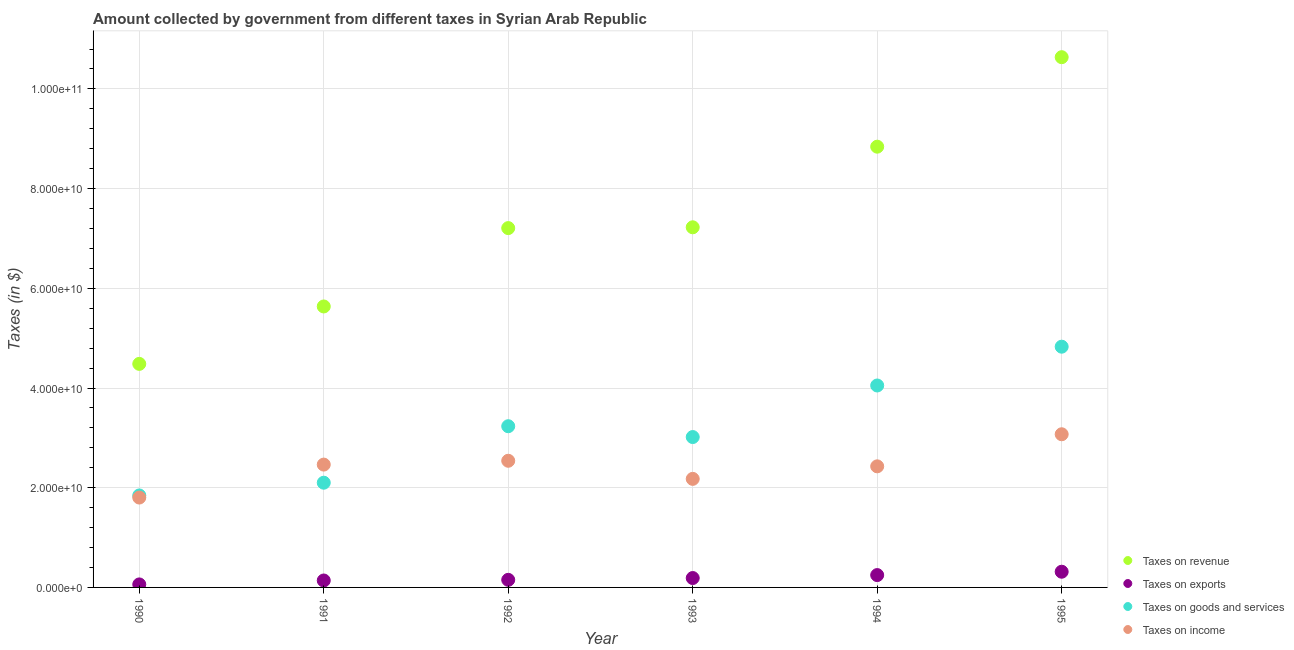How many different coloured dotlines are there?
Give a very brief answer. 4. Is the number of dotlines equal to the number of legend labels?
Keep it short and to the point. Yes. What is the amount collected as tax on exports in 1992?
Provide a succinct answer. 1.52e+09. Across all years, what is the maximum amount collected as tax on income?
Your answer should be very brief. 3.07e+1. Across all years, what is the minimum amount collected as tax on income?
Offer a terse response. 1.80e+1. In which year was the amount collected as tax on revenue maximum?
Make the answer very short. 1995. In which year was the amount collected as tax on goods minimum?
Offer a terse response. 1990. What is the total amount collected as tax on goods in the graph?
Provide a short and direct response. 1.91e+11. What is the difference between the amount collected as tax on revenue in 1991 and that in 1992?
Provide a short and direct response. -1.57e+1. What is the difference between the amount collected as tax on revenue in 1994 and the amount collected as tax on exports in 1995?
Give a very brief answer. 8.53e+1. What is the average amount collected as tax on exports per year?
Offer a terse response. 1.84e+09. In the year 1991, what is the difference between the amount collected as tax on goods and amount collected as tax on revenue?
Ensure brevity in your answer.  -3.54e+1. What is the ratio of the amount collected as tax on exports in 1990 to that in 1991?
Offer a terse response. 0.43. Is the amount collected as tax on exports in 1991 less than that in 1995?
Ensure brevity in your answer.  Yes. What is the difference between the highest and the second highest amount collected as tax on goods?
Offer a very short reply. 7.78e+09. What is the difference between the highest and the lowest amount collected as tax on exports?
Offer a terse response. 2.54e+09. Is it the case that in every year, the sum of the amount collected as tax on goods and amount collected as tax on exports is greater than the sum of amount collected as tax on income and amount collected as tax on revenue?
Ensure brevity in your answer.  Yes. Does the amount collected as tax on exports monotonically increase over the years?
Your answer should be very brief. Yes. How many dotlines are there?
Offer a very short reply. 4. What is the difference between two consecutive major ticks on the Y-axis?
Offer a terse response. 2.00e+1. How are the legend labels stacked?
Your response must be concise. Vertical. What is the title of the graph?
Ensure brevity in your answer.  Amount collected by government from different taxes in Syrian Arab Republic. Does "Coal" appear as one of the legend labels in the graph?
Give a very brief answer. No. What is the label or title of the X-axis?
Give a very brief answer. Year. What is the label or title of the Y-axis?
Give a very brief answer. Taxes (in $). What is the Taxes (in $) in Taxes on revenue in 1990?
Provide a succinct answer. 4.48e+1. What is the Taxes (in $) in Taxes on exports in 1990?
Your response must be concise. 6.04e+08. What is the Taxes (in $) of Taxes on goods and services in 1990?
Ensure brevity in your answer.  1.85e+1. What is the Taxes (in $) of Taxes on income in 1990?
Your answer should be compact. 1.80e+1. What is the Taxes (in $) of Taxes on revenue in 1991?
Ensure brevity in your answer.  5.64e+1. What is the Taxes (in $) of Taxes on exports in 1991?
Your answer should be compact. 1.39e+09. What is the Taxes (in $) in Taxes on goods and services in 1991?
Keep it short and to the point. 2.10e+1. What is the Taxes (in $) of Taxes on income in 1991?
Make the answer very short. 2.46e+1. What is the Taxes (in $) of Taxes on revenue in 1992?
Ensure brevity in your answer.  7.21e+1. What is the Taxes (in $) in Taxes on exports in 1992?
Ensure brevity in your answer.  1.52e+09. What is the Taxes (in $) in Taxes on goods and services in 1992?
Give a very brief answer. 3.23e+1. What is the Taxes (in $) in Taxes on income in 1992?
Keep it short and to the point. 2.54e+1. What is the Taxes (in $) in Taxes on revenue in 1993?
Offer a terse response. 7.22e+1. What is the Taxes (in $) in Taxes on exports in 1993?
Make the answer very short. 1.88e+09. What is the Taxes (in $) in Taxes on goods and services in 1993?
Your answer should be compact. 3.02e+1. What is the Taxes (in $) of Taxes on income in 1993?
Your answer should be very brief. 2.18e+1. What is the Taxes (in $) of Taxes on revenue in 1994?
Ensure brevity in your answer.  8.84e+1. What is the Taxes (in $) in Taxes on exports in 1994?
Provide a succinct answer. 2.48e+09. What is the Taxes (in $) in Taxes on goods and services in 1994?
Offer a very short reply. 4.05e+1. What is the Taxes (in $) in Taxes on income in 1994?
Your answer should be very brief. 2.43e+1. What is the Taxes (in $) of Taxes on revenue in 1995?
Your response must be concise. 1.06e+11. What is the Taxes (in $) in Taxes on exports in 1995?
Ensure brevity in your answer.  3.15e+09. What is the Taxes (in $) in Taxes on goods and services in 1995?
Give a very brief answer. 4.83e+1. What is the Taxes (in $) of Taxes on income in 1995?
Provide a succinct answer. 3.07e+1. Across all years, what is the maximum Taxes (in $) in Taxes on revenue?
Make the answer very short. 1.06e+11. Across all years, what is the maximum Taxes (in $) of Taxes on exports?
Keep it short and to the point. 3.15e+09. Across all years, what is the maximum Taxes (in $) in Taxes on goods and services?
Provide a succinct answer. 4.83e+1. Across all years, what is the maximum Taxes (in $) of Taxes on income?
Provide a short and direct response. 3.07e+1. Across all years, what is the minimum Taxes (in $) in Taxes on revenue?
Provide a short and direct response. 4.48e+1. Across all years, what is the minimum Taxes (in $) of Taxes on exports?
Offer a terse response. 6.04e+08. Across all years, what is the minimum Taxes (in $) of Taxes on goods and services?
Provide a short and direct response. 1.85e+1. Across all years, what is the minimum Taxes (in $) of Taxes on income?
Your response must be concise. 1.80e+1. What is the total Taxes (in $) in Taxes on revenue in the graph?
Keep it short and to the point. 4.40e+11. What is the total Taxes (in $) in Taxes on exports in the graph?
Keep it short and to the point. 1.10e+1. What is the total Taxes (in $) of Taxes on goods and services in the graph?
Your answer should be compact. 1.91e+11. What is the total Taxes (in $) of Taxes on income in the graph?
Give a very brief answer. 1.45e+11. What is the difference between the Taxes (in $) in Taxes on revenue in 1990 and that in 1991?
Keep it short and to the point. -1.15e+1. What is the difference between the Taxes (in $) of Taxes on exports in 1990 and that in 1991?
Your answer should be very brief. -7.88e+08. What is the difference between the Taxes (in $) of Taxes on goods and services in 1990 and that in 1991?
Provide a succinct answer. -2.56e+09. What is the difference between the Taxes (in $) in Taxes on income in 1990 and that in 1991?
Provide a short and direct response. -6.61e+09. What is the difference between the Taxes (in $) of Taxes on revenue in 1990 and that in 1992?
Your answer should be compact. -2.72e+1. What is the difference between the Taxes (in $) in Taxes on exports in 1990 and that in 1992?
Provide a succinct answer. -9.19e+08. What is the difference between the Taxes (in $) in Taxes on goods and services in 1990 and that in 1992?
Keep it short and to the point. -1.39e+1. What is the difference between the Taxes (in $) in Taxes on income in 1990 and that in 1992?
Your answer should be very brief. -7.38e+09. What is the difference between the Taxes (in $) of Taxes on revenue in 1990 and that in 1993?
Give a very brief answer. -2.74e+1. What is the difference between the Taxes (in $) of Taxes on exports in 1990 and that in 1993?
Offer a terse response. -1.28e+09. What is the difference between the Taxes (in $) of Taxes on goods and services in 1990 and that in 1993?
Your answer should be compact. -1.17e+1. What is the difference between the Taxes (in $) in Taxes on income in 1990 and that in 1993?
Give a very brief answer. -3.75e+09. What is the difference between the Taxes (in $) in Taxes on revenue in 1990 and that in 1994?
Provide a succinct answer. -4.36e+1. What is the difference between the Taxes (in $) of Taxes on exports in 1990 and that in 1994?
Keep it short and to the point. -1.87e+09. What is the difference between the Taxes (in $) of Taxes on goods and services in 1990 and that in 1994?
Make the answer very short. -2.21e+1. What is the difference between the Taxes (in $) in Taxes on income in 1990 and that in 1994?
Give a very brief answer. -6.26e+09. What is the difference between the Taxes (in $) of Taxes on revenue in 1990 and that in 1995?
Your response must be concise. -6.15e+1. What is the difference between the Taxes (in $) of Taxes on exports in 1990 and that in 1995?
Your response must be concise. -2.54e+09. What is the difference between the Taxes (in $) of Taxes on goods and services in 1990 and that in 1995?
Ensure brevity in your answer.  -2.98e+1. What is the difference between the Taxes (in $) in Taxes on income in 1990 and that in 1995?
Your response must be concise. -1.27e+1. What is the difference between the Taxes (in $) of Taxes on revenue in 1991 and that in 1992?
Provide a succinct answer. -1.57e+1. What is the difference between the Taxes (in $) in Taxes on exports in 1991 and that in 1992?
Give a very brief answer. -1.31e+08. What is the difference between the Taxes (in $) in Taxes on goods and services in 1991 and that in 1992?
Offer a terse response. -1.13e+1. What is the difference between the Taxes (in $) of Taxes on income in 1991 and that in 1992?
Your answer should be compact. -7.67e+08. What is the difference between the Taxes (in $) in Taxes on revenue in 1991 and that in 1993?
Ensure brevity in your answer.  -1.59e+1. What is the difference between the Taxes (in $) of Taxes on exports in 1991 and that in 1993?
Your answer should be very brief. -4.92e+08. What is the difference between the Taxes (in $) of Taxes on goods and services in 1991 and that in 1993?
Make the answer very short. -9.16e+09. What is the difference between the Taxes (in $) in Taxes on income in 1991 and that in 1993?
Provide a short and direct response. 2.86e+09. What is the difference between the Taxes (in $) of Taxes on revenue in 1991 and that in 1994?
Offer a terse response. -3.21e+1. What is the difference between the Taxes (in $) of Taxes on exports in 1991 and that in 1994?
Provide a succinct answer. -1.08e+09. What is the difference between the Taxes (in $) of Taxes on goods and services in 1991 and that in 1994?
Your answer should be very brief. -1.95e+1. What is the difference between the Taxes (in $) in Taxes on income in 1991 and that in 1994?
Your answer should be compact. 3.50e+08. What is the difference between the Taxes (in $) of Taxes on revenue in 1991 and that in 1995?
Offer a terse response. -5.00e+1. What is the difference between the Taxes (in $) of Taxes on exports in 1991 and that in 1995?
Your answer should be compact. -1.76e+09. What is the difference between the Taxes (in $) in Taxes on goods and services in 1991 and that in 1995?
Provide a short and direct response. -2.73e+1. What is the difference between the Taxes (in $) of Taxes on income in 1991 and that in 1995?
Your response must be concise. -6.08e+09. What is the difference between the Taxes (in $) in Taxes on revenue in 1992 and that in 1993?
Provide a short and direct response. -1.62e+08. What is the difference between the Taxes (in $) of Taxes on exports in 1992 and that in 1993?
Make the answer very short. -3.61e+08. What is the difference between the Taxes (in $) in Taxes on goods and services in 1992 and that in 1993?
Offer a very short reply. 2.17e+09. What is the difference between the Taxes (in $) in Taxes on income in 1992 and that in 1993?
Offer a very short reply. 3.63e+09. What is the difference between the Taxes (in $) in Taxes on revenue in 1992 and that in 1994?
Provide a succinct answer. -1.63e+1. What is the difference between the Taxes (in $) in Taxes on exports in 1992 and that in 1994?
Your answer should be very brief. -9.54e+08. What is the difference between the Taxes (in $) of Taxes on goods and services in 1992 and that in 1994?
Provide a short and direct response. -8.17e+09. What is the difference between the Taxes (in $) in Taxes on income in 1992 and that in 1994?
Offer a very short reply. 1.12e+09. What is the difference between the Taxes (in $) in Taxes on revenue in 1992 and that in 1995?
Your response must be concise. -3.43e+1. What is the difference between the Taxes (in $) of Taxes on exports in 1992 and that in 1995?
Offer a very short reply. -1.63e+09. What is the difference between the Taxes (in $) of Taxes on goods and services in 1992 and that in 1995?
Ensure brevity in your answer.  -1.60e+1. What is the difference between the Taxes (in $) in Taxes on income in 1992 and that in 1995?
Your answer should be compact. -5.32e+09. What is the difference between the Taxes (in $) of Taxes on revenue in 1993 and that in 1994?
Make the answer very short. -1.62e+1. What is the difference between the Taxes (in $) in Taxes on exports in 1993 and that in 1994?
Offer a very short reply. -5.93e+08. What is the difference between the Taxes (in $) of Taxes on goods and services in 1993 and that in 1994?
Make the answer very short. -1.03e+1. What is the difference between the Taxes (in $) of Taxes on income in 1993 and that in 1994?
Offer a very short reply. -2.52e+09. What is the difference between the Taxes (in $) in Taxes on revenue in 1993 and that in 1995?
Your answer should be compact. -3.41e+1. What is the difference between the Taxes (in $) of Taxes on exports in 1993 and that in 1995?
Your response must be concise. -1.26e+09. What is the difference between the Taxes (in $) of Taxes on goods and services in 1993 and that in 1995?
Give a very brief answer. -1.81e+1. What is the difference between the Taxes (in $) of Taxes on income in 1993 and that in 1995?
Your answer should be very brief. -8.95e+09. What is the difference between the Taxes (in $) in Taxes on revenue in 1994 and that in 1995?
Ensure brevity in your answer.  -1.80e+1. What is the difference between the Taxes (in $) in Taxes on exports in 1994 and that in 1995?
Keep it short and to the point. -6.72e+08. What is the difference between the Taxes (in $) in Taxes on goods and services in 1994 and that in 1995?
Offer a very short reply. -7.78e+09. What is the difference between the Taxes (in $) of Taxes on income in 1994 and that in 1995?
Offer a very short reply. -6.43e+09. What is the difference between the Taxes (in $) in Taxes on revenue in 1990 and the Taxes (in $) in Taxes on exports in 1991?
Your response must be concise. 4.35e+1. What is the difference between the Taxes (in $) of Taxes on revenue in 1990 and the Taxes (in $) of Taxes on goods and services in 1991?
Offer a very short reply. 2.38e+1. What is the difference between the Taxes (in $) of Taxes on revenue in 1990 and the Taxes (in $) of Taxes on income in 1991?
Provide a succinct answer. 2.02e+1. What is the difference between the Taxes (in $) of Taxes on exports in 1990 and the Taxes (in $) of Taxes on goods and services in 1991?
Your response must be concise. -2.04e+1. What is the difference between the Taxes (in $) in Taxes on exports in 1990 and the Taxes (in $) in Taxes on income in 1991?
Your answer should be very brief. -2.40e+1. What is the difference between the Taxes (in $) of Taxes on goods and services in 1990 and the Taxes (in $) of Taxes on income in 1991?
Your response must be concise. -6.19e+09. What is the difference between the Taxes (in $) of Taxes on revenue in 1990 and the Taxes (in $) of Taxes on exports in 1992?
Make the answer very short. 4.33e+1. What is the difference between the Taxes (in $) in Taxes on revenue in 1990 and the Taxes (in $) in Taxes on goods and services in 1992?
Provide a short and direct response. 1.25e+1. What is the difference between the Taxes (in $) in Taxes on revenue in 1990 and the Taxes (in $) in Taxes on income in 1992?
Provide a short and direct response. 1.94e+1. What is the difference between the Taxes (in $) in Taxes on exports in 1990 and the Taxes (in $) in Taxes on goods and services in 1992?
Offer a very short reply. -3.17e+1. What is the difference between the Taxes (in $) in Taxes on exports in 1990 and the Taxes (in $) in Taxes on income in 1992?
Offer a very short reply. -2.48e+1. What is the difference between the Taxes (in $) in Taxes on goods and services in 1990 and the Taxes (in $) in Taxes on income in 1992?
Your answer should be very brief. -6.96e+09. What is the difference between the Taxes (in $) of Taxes on revenue in 1990 and the Taxes (in $) of Taxes on exports in 1993?
Your response must be concise. 4.30e+1. What is the difference between the Taxes (in $) in Taxes on revenue in 1990 and the Taxes (in $) in Taxes on goods and services in 1993?
Provide a succinct answer. 1.47e+1. What is the difference between the Taxes (in $) in Taxes on revenue in 1990 and the Taxes (in $) in Taxes on income in 1993?
Offer a very short reply. 2.31e+1. What is the difference between the Taxes (in $) in Taxes on exports in 1990 and the Taxes (in $) in Taxes on goods and services in 1993?
Keep it short and to the point. -2.96e+1. What is the difference between the Taxes (in $) in Taxes on exports in 1990 and the Taxes (in $) in Taxes on income in 1993?
Make the answer very short. -2.12e+1. What is the difference between the Taxes (in $) in Taxes on goods and services in 1990 and the Taxes (in $) in Taxes on income in 1993?
Keep it short and to the point. -3.32e+09. What is the difference between the Taxes (in $) of Taxes on revenue in 1990 and the Taxes (in $) of Taxes on exports in 1994?
Make the answer very short. 4.24e+1. What is the difference between the Taxes (in $) in Taxes on revenue in 1990 and the Taxes (in $) in Taxes on goods and services in 1994?
Ensure brevity in your answer.  4.34e+09. What is the difference between the Taxes (in $) of Taxes on revenue in 1990 and the Taxes (in $) of Taxes on income in 1994?
Keep it short and to the point. 2.06e+1. What is the difference between the Taxes (in $) of Taxes on exports in 1990 and the Taxes (in $) of Taxes on goods and services in 1994?
Offer a terse response. -3.99e+1. What is the difference between the Taxes (in $) of Taxes on exports in 1990 and the Taxes (in $) of Taxes on income in 1994?
Provide a short and direct response. -2.37e+1. What is the difference between the Taxes (in $) in Taxes on goods and services in 1990 and the Taxes (in $) in Taxes on income in 1994?
Offer a terse response. -5.84e+09. What is the difference between the Taxes (in $) in Taxes on revenue in 1990 and the Taxes (in $) in Taxes on exports in 1995?
Offer a very short reply. 4.17e+1. What is the difference between the Taxes (in $) of Taxes on revenue in 1990 and the Taxes (in $) of Taxes on goods and services in 1995?
Keep it short and to the point. -3.45e+09. What is the difference between the Taxes (in $) in Taxes on revenue in 1990 and the Taxes (in $) in Taxes on income in 1995?
Offer a terse response. 1.41e+1. What is the difference between the Taxes (in $) in Taxes on exports in 1990 and the Taxes (in $) in Taxes on goods and services in 1995?
Provide a short and direct response. -4.77e+1. What is the difference between the Taxes (in $) in Taxes on exports in 1990 and the Taxes (in $) in Taxes on income in 1995?
Make the answer very short. -3.01e+1. What is the difference between the Taxes (in $) of Taxes on goods and services in 1990 and the Taxes (in $) of Taxes on income in 1995?
Your answer should be very brief. -1.23e+1. What is the difference between the Taxes (in $) in Taxes on revenue in 1991 and the Taxes (in $) in Taxes on exports in 1992?
Ensure brevity in your answer.  5.48e+1. What is the difference between the Taxes (in $) in Taxes on revenue in 1991 and the Taxes (in $) in Taxes on goods and services in 1992?
Provide a succinct answer. 2.40e+1. What is the difference between the Taxes (in $) in Taxes on revenue in 1991 and the Taxes (in $) in Taxes on income in 1992?
Give a very brief answer. 3.10e+1. What is the difference between the Taxes (in $) of Taxes on exports in 1991 and the Taxes (in $) of Taxes on goods and services in 1992?
Keep it short and to the point. -3.09e+1. What is the difference between the Taxes (in $) of Taxes on exports in 1991 and the Taxes (in $) of Taxes on income in 1992?
Ensure brevity in your answer.  -2.40e+1. What is the difference between the Taxes (in $) of Taxes on goods and services in 1991 and the Taxes (in $) of Taxes on income in 1992?
Provide a succinct answer. -4.40e+09. What is the difference between the Taxes (in $) in Taxes on revenue in 1991 and the Taxes (in $) in Taxes on exports in 1993?
Make the answer very short. 5.45e+1. What is the difference between the Taxes (in $) of Taxes on revenue in 1991 and the Taxes (in $) of Taxes on goods and services in 1993?
Your answer should be compact. 2.62e+1. What is the difference between the Taxes (in $) in Taxes on revenue in 1991 and the Taxes (in $) in Taxes on income in 1993?
Your answer should be very brief. 3.46e+1. What is the difference between the Taxes (in $) of Taxes on exports in 1991 and the Taxes (in $) of Taxes on goods and services in 1993?
Keep it short and to the point. -2.88e+1. What is the difference between the Taxes (in $) of Taxes on exports in 1991 and the Taxes (in $) of Taxes on income in 1993?
Give a very brief answer. -2.04e+1. What is the difference between the Taxes (in $) in Taxes on goods and services in 1991 and the Taxes (in $) in Taxes on income in 1993?
Your response must be concise. -7.69e+08. What is the difference between the Taxes (in $) of Taxes on revenue in 1991 and the Taxes (in $) of Taxes on exports in 1994?
Offer a terse response. 5.39e+1. What is the difference between the Taxes (in $) of Taxes on revenue in 1991 and the Taxes (in $) of Taxes on goods and services in 1994?
Keep it short and to the point. 1.59e+1. What is the difference between the Taxes (in $) in Taxes on revenue in 1991 and the Taxes (in $) in Taxes on income in 1994?
Ensure brevity in your answer.  3.21e+1. What is the difference between the Taxes (in $) of Taxes on exports in 1991 and the Taxes (in $) of Taxes on goods and services in 1994?
Your answer should be very brief. -3.91e+1. What is the difference between the Taxes (in $) in Taxes on exports in 1991 and the Taxes (in $) in Taxes on income in 1994?
Your answer should be very brief. -2.29e+1. What is the difference between the Taxes (in $) in Taxes on goods and services in 1991 and the Taxes (in $) in Taxes on income in 1994?
Your answer should be compact. -3.28e+09. What is the difference between the Taxes (in $) of Taxes on revenue in 1991 and the Taxes (in $) of Taxes on exports in 1995?
Your answer should be very brief. 5.32e+1. What is the difference between the Taxes (in $) in Taxes on revenue in 1991 and the Taxes (in $) in Taxes on goods and services in 1995?
Your answer should be compact. 8.07e+09. What is the difference between the Taxes (in $) in Taxes on revenue in 1991 and the Taxes (in $) in Taxes on income in 1995?
Provide a succinct answer. 2.56e+1. What is the difference between the Taxes (in $) of Taxes on exports in 1991 and the Taxes (in $) of Taxes on goods and services in 1995?
Your answer should be compact. -4.69e+1. What is the difference between the Taxes (in $) of Taxes on exports in 1991 and the Taxes (in $) of Taxes on income in 1995?
Offer a very short reply. -2.93e+1. What is the difference between the Taxes (in $) in Taxes on goods and services in 1991 and the Taxes (in $) in Taxes on income in 1995?
Provide a short and direct response. -9.72e+09. What is the difference between the Taxes (in $) in Taxes on revenue in 1992 and the Taxes (in $) in Taxes on exports in 1993?
Provide a short and direct response. 7.02e+1. What is the difference between the Taxes (in $) in Taxes on revenue in 1992 and the Taxes (in $) in Taxes on goods and services in 1993?
Provide a short and direct response. 4.19e+1. What is the difference between the Taxes (in $) in Taxes on revenue in 1992 and the Taxes (in $) in Taxes on income in 1993?
Provide a succinct answer. 5.03e+1. What is the difference between the Taxes (in $) of Taxes on exports in 1992 and the Taxes (in $) of Taxes on goods and services in 1993?
Provide a short and direct response. -2.86e+1. What is the difference between the Taxes (in $) of Taxes on exports in 1992 and the Taxes (in $) of Taxes on income in 1993?
Provide a succinct answer. -2.03e+1. What is the difference between the Taxes (in $) in Taxes on goods and services in 1992 and the Taxes (in $) in Taxes on income in 1993?
Ensure brevity in your answer.  1.06e+1. What is the difference between the Taxes (in $) in Taxes on revenue in 1992 and the Taxes (in $) in Taxes on exports in 1994?
Your answer should be compact. 6.96e+1. What is the difference between the Taxes (in $) of Taxes on revenue in 1992 and the Taxes (in $) of Taxes on goods and services in 1994?
Offer a terse response. 3.16e+1. What is the difference between the Taxes (in $) in Taxes on revenue in 1992 and the Taxes (in $) in Taxes on income in 1994?
Provide a succinct answer. 4.78e+1. What is the difference between the Taxes (in $) of Taxes on exports in 1992 and the Taxes (in $) of Taxes on goods and services in 1994?
Give a very brief answer. -3.90e+1. What is the difference between the Taxes (in $) of Taxes on exports in 1992 and the Taxes (in $) of Taxes on income in 1994?
Keep it short and to the point. -2.28e+1. What is the difference between the Taxes (in $) of Taxes on goods and services in 1992 and the Taxes (in $) of Taxes on income in 1994?
Provide a short and direct response. 8.05e+09. What is the difference between the Taxes (in $) of Taxes on revenue in 1992 and the Taxes (in $) of Taxes on exports in 1995?
Offer a terse response. 6.89e+1. What is the difference between the Taxes (in $) of Taxes on revenue in 1992 and the Taxes (in $) of Taxes on goods and services in 1995?
Your answer should be compact. 2.38e+1. What is the difference between the Taxes (in $) of Taxes on revenue in 1992 and the Taxes (in $) of Taxes on income in 1995?
Ensure brevity in your answer.  4.14e+1. What is the difference between the Taxes (in $) in Taxes on exports in 1992 and the Taxes (in $) in Taxes on goods and services in 1995?
Keep it short and to the point. -4.68e+1. What is the difference between the Taxes (in $) in Taxes on exports in 1992 and the Taxes (in $) in Taxes on income in 1995?
Keep it short and to the point. -2.92e+1. What is the difference between the Taxes (in $) of Taxes on goods and services in 1992 and the Taxes (in $) of Taxes on income in 1995?
Provide a short and direct response. 1.61e+09. What is the difference between the Taxes (in $) in Taxes on revenue in 1993 and the Taxes (in $) in Taxes on exports in 1994?
Your answer should be compact. 6.98e+1. What is the difference between the Taxes (in $) in Taxes on revenue in 1993 and the Taxes (in $) in Taxes on goods and services in 1994?
Provide a succinct answer. 3.17e+1. What is the difference between the Taxes (in $) of Taxes on revenue in 1993 and the Taxes (in $) of Taxes on income in 1994?
Provide a short and direct response. 4.80e+1. What is the difference between the Taxes (in $) in Taxes on exports in 1993 and the Taxes (in $) in Taxes on goods and services in 1994?
Your answer should be very brief. -3.86e+1. What is the difference between the Taxes (in $) in Taxes on exports in 1993 and the Taxes (in $) in Taxes on income in 1994?
Offer a very short reply. -2.24e+1. What is the difference between the Taxes (in $) of Taxes on goods and services in 1993 and the Taxes (in $) of Taxes on income in 1994?
Provide a short and direct response. 5.88e+09. What is the difference between the Taxes (in $) in Taxes on revenue in 1993 and the Taxes (in $) in Taxes on exports in 1995?
Your answer should be very brief. 6.91e+1. What is the difference between the Taxes (in $) of Taxes on revenue in 1993 and the Taxes (in $) of Taxes on goods and services in 1995?
Offer a very short reply. 2.40e+1. What is the difference between the Taxes (in $) of Taxes on revenue in 1993 and the Taxes (in $) of Taxes on income in 1995?
Offer a very short reply. 4.15e+1. What is the difference between the Taxes (in $) of Taxes on exports in 1993 and the Taxes (in $) of Taxes on goods and services in 1995?
Offer a very short reply. -4.64e+1. What is the difference between the Taxes (in $) of Taxes on exports in 1993 and the Taxes (in $) of Taxes on income in 1995?
Offer a very short reply. -2.88e+1. What is the difference between the Taxes (in $) in Taxes on goods and services in 1993 and the Taxes (in $) in Taxes on income in 1995?
Offer a very short reply. -5.59e+08. What is the difference between the Taxes (in $) of Taxes on revenue in 1994 and the Taxes (in $) of Taxes on exports in 1995?
Offer a terse response. 8.53e+1. What is the difference between the Taxes (in $) in Taxes on revenue in 1994 and the Taxes (in $) in Taxes on goods and services in 1995?
Offer a terse response. 4.01e+1. What is the difference between the Taxes (in $) of Taxes on revenue in 1994 and the Taxes (in $) of Taxes on income in 1995?
Ensure brevity in your answer.  5.77e+1. What is the difference between the Taxes (in $) in Taxes on exports in 1994 and the Taxes (in $) in Taxes on goods and services in 1995?
Make the answer very short. -4.58e+1. What is the difference between the Taxes (in $) in Taxes on exports in 1994 and the Taxes (in $) in Taxes on income in 1995?
Make the answer very short. -2.82e+1. What is the difference between the Taxes (in $) of Taxes on goods and services in 1994 and the Taxes (in $) of Taxes on income in 1995?
Your answer should be very brief. 9.78e+09. What is the average Taxes (in $) in Taxes on revenue per year?
Provide a short and direct response. 7.34e+1. What is the average Taxes (in $) in Taxes on exports per year?
Keep it short and to the point. 1.84e+09. What is the average Taxes (in $) of Taxes on goods and services per year?
Your answer should be very brief. 3.18e+1. What is the average Taxes (in $) in Taxes on income per year?
Provide a succinct answer. 2.41e+1. In the year 1990, what is the difference between the Taxes (in $) in Taxes on revenue and Taxes (in $) in Taxes on exports?
Keep it short and to the point. 4.42e+1. In the year 1990, what is the difference between the Taxes (in $) of Taxes on revenue and Taxes (in $) of Taxes on goods and services?
Offer a very short reply. 2.64e+1. In the year 1990, what is the difference between the Taxes (in $) in Taxes on revenue and Taxes (in $) in Taxes on income?
Your answer should be compact. 2.68e+1. In the year 1990, what is the difference between the Taxes (in $) of Taxes on exports and Taxes (in $) of Taxes on goods and services?
Your answer should be very brief. -1.78e+1. In the year 1990, what is the difference between the Taxes (in $) of Taxes on exports and Taxes (in $) of Taxes on income?
Offer a terse response. -1.74e+1. In the year 1990, what is the difference between the Taxes (in $) of Taxes on goods and services and Taxes (in $) of Taxes on income?
Keep it short and to the point. 4.23e+08. In the year 1991, what is the difference between the Taxes (in $) in Taxes on revenue and Taxes (in $) in Taxes on exports?
Your response must be concise. 5.50e+1. In the year 1991, what is the difference between the Taxes (in $) in Taxes on revenue and Taxes (in $) in Taxes on goods and services?
Ensure brevity in your answer.  3.54e+1. In the year 1991, what is the difference between the Taxes (in $) of Taxes on revenue and Taxes (in $) of Taxes on income?
Your response must be concise. 3.17e+1. In the year 1991, what is the difference between the Taxes (in $) of Taxes on exports and Taxes (in $) of Taxes on goods and services?
Give a very brief answer. -1.96e+1. In the year 1991, what is the difference between the Taxes (in $) in Taxes on exports and Taxes (in $) in Taxes on income?
Provide a succinct answer. -2.32e+1. In the year 1991, what is the difference between the Taxes (in $) in Taxes on goods and services and Taxes (in $) in Taxes on income?
Give a very brief answer. -3.63e+09. In the year 1992, what is the difference between the Taxes (in $) of Taxes on revenue and Taxes (in $) of Taxes on exports?
Your answer should be very brief. 7.06e+1. In the year 1992, what is the difference between the Taxes (in $) of Taxes on revenue and Taxes (in $) of Taxes on goods and services?
Your answer should be compact. 3.97e+1. In the year 1992, what is the difference between the Taxes (in $) in Taxes on revenue and Taxes (in $) in Taxes on income?
Your answer should be compact. 4.67e+1. In the year 1992, what is the difference between the Taxes (in $) in Taxes on exports and Taxes (in $) in Taxes on goods and services?
Provide a succinct answer. -3.08e+1. In the year 1992, what is the difference between the Taxes (in $) of Taxes on exports and Taxes (in $) of Taxes on income?
Keep it short and to the point. -2.39e+1. In the year 1992, what is the difference between the Taxes (in $) in Taxes on goods and services and Taxes (in $) in Taxes on income?
Provide a succinct answer. 6.93e+09. In the year 1993, what is the difference between the Taxes (in $) of Taxes on revenue and Taxes (in $) of Taxes on exports?
Give a very brief answer. 7.04e+1. In the year 1993, what is the difference between the Taxes (in $) of Taxes on revenue and Taxes (in $) of Taxes on goods and services?
Provide a short and direct response. 4.21e+1. In the year 1993, what is the difference between the Taxes (in $) of Taxes on revenue and Taxes (in $) of Taxes on income?
Offer a very short reply. 5.05e+1. In the year 1993, what is the difference between the Taxes (in $) in Taxes on exports and Taxes (in $) in Taxes on goods and services?
Give a very brief answer. -2.83e+1. In the year 1993, what is the difference between the Taxes (in $) of Taxes on exports and Taxes (in $) of Taxes on income?
Your answer should be very brief. -1.99e+1. In the year 1993, what is the difference between the Taxes (in $) of Taxes on goods and services and Taxes (in $) of Taxes on income?
Your response must be concise. 8.39e+09. In the year 1994, what is the difference between the Taxes (in $) in Taxes on revenue and Taxes (in $) in Taxes on exports?
Offer a very short reply. 8.59e+1. In the year 1994, what is the difference between the Taxes (in $) of Taxes on revenue and Taxes (in $) of Taxes on goods and services?
Your answer should be compact. 4.79e+1. In the year 1994, what is the difference between the Taxes (in $) of Taxes on revenue and Taxes (in $) of Taxes on income?
Provide a succinct answer. 6.41e+1. In the year 1994, what is the difference between the Taxes (in $) in Taxes on exports and Taxes (in $) in Taxes on goods and services?
Make the answer very short. -3.80e+1. In the year 1994, what is the difference between the Taxes (in $) of Taxes on exports and Taxes (in $) of Taxes on income?
Your answer should be compact. -2.18e+1. In the year 1994, what is the difference between the Taxes (in $) of Taxes on goods and services and Taxes (in $) of Taxes on income?
Your answer should be compact. 1.62e+1. In the year 1995, what is the difference between the Taxes (in $) in Taxes on revenue and Taxes (in $) in Taxes on exports?
Give a very brief answer. 1.03e+11. In the year 1995, what is the difference between the Taxes (in $) in Taxes on revenue and Taxes (in $) in Taxes on goods and services?
Ensure brevity in your answer.  5.81e+1. In the year 1995, what is the difference between the Taxes (in $) in Taxes on revenue and Taxes (in $) in Taxes on income?
Offer a terse response. 7.56e+1. In the year 1995, what is the difference between the Taxes (in $) in Taxes on exports and Taxes (in $) in Taxes on goods and services?
Make the answer very short. -4.51e+1. In the year 1995, what is the difference between the Taxes (in $) in Taxes on exports and Taxes (in $) in Taxes on income?
Your response must be concise. -2.76e+1. In the year 1995, what is the difference between the Taxes (in $) of Taxes on goods and services and Taxes (in $) of Taxes on income?
Keep it short and to the point. 1.76e+1. What is the ratio of the Taxes (in $) in Taxes on revenue in 1990 to that in 1991?
Your answer should be very brief. 0.8. What is the ratio of the Taxes (in $) of Taxes on exports in 1990 to that in 1991?
Offer a terse response. 0.43. What is the ratio of the Taxes (in $) in Taxes on goods and services in 1990 to that in 1991?
Offer a very short reply. 0.88. What is the ratio of the Taxes (in $) of Taxes on income in 1990 to that in 1991?
Give a very brief answer. 0.73. What is the ratio of the Taxes (in $) in Taxes on revenue in 1990 to that in 1992?
Offer a terse response. 0.62. What is the ratio of the Taxes (in $) in Taxes on exports in 1990 to that in 1992?
Provide a short and direct response. 0.4. What is the ratio of the Taxes (in $) of Taxes on goods and services in 1990 to that in 1992?
Your response must be concise. 0.57. What is the ratio of the Taxes (in $) of Taxes on income in 1990 to that in 1992?
Offer a very short reply. 0.71. What is the ratio of the Taxes (in $) of Taxes on revenue in 1990 to that in 1993?
Provide a short and direct response. 0.62. What is the ratio of the Taxes (in $) of Taxes on exports in 1990 to that in 1993?
Provide a short and direct response. 0.32. What is the ratio of the Taxes (in $) in Taxes on goods and services in 1990 to that in 1993?
Keep it short and to the point. 0.61. What is the ratio of the Taxes (in $) of Taxes on income in 1990 to that in 1993?
Your answer should be compact. 0.83. What is the ratio of the Taxes (in $) in Taxes on revenue in 1990 to that in 1994?
Provide a succinct answer. 0.51. What is the ratio of the Taxes (in $) in Taxes on exports in 1990 to that in 1994?
Provide a short and direct response. 0.24. What is the ratio of the Taxes (in $) in Taxes on goods and services in 1990 to that in 1994?
Provide a short and direct response. 0.46. What is the ratio of the Taxes (in $) in Taxes on income in 1990 to that in 1994?
Make the answer very short. 0.74. What is the ratio of the Taxes (in $) in Taxes on revenue in 1990 to that in 1995?
Give a very brief answer. 0.42. What is the ratio of the Taxes (in $) of Taxes on exports in 1990 to that in 1995?
Offer a very short reply. 0.19. What is the ratio of the Taxes (in $) of Taxes on goods and services in 1990 to that in 1995?
Your answer should be very brief. 0.38. What is the ratio of the Taxes (in $) of Taxes on income in 1990 to that in 1995?
Offer a very short reply. 0.59. What is the ratio of the Taxes (in $) of Taxes on revenue in 1991 to that in 1992?
Your answer should be compact. 0.78. What is the ratio of the Taxes (in $) in Taxes on exports in 1991 to that in 1992?
Ensure brevity in your answer.  0.91. What is the ratio of the Taxes (in $) of Taxes on goods and services in 1991 to that in 1992?
Keep it short and to the point. 0.65. What is the ratio of the Taxes (in $) in Taxes on income in 1991 to that in 1992?
Ensure brevity in your answer.  0.97. What is the ratio of the Taxes (in $) of Taxes on revenue in 1991 to that in 1993?
Offer a very short reply. 0.78. What is the ratio of the Taxes (in $) of Taxes on exports in 1991 to that in 1993?
Your answer should be compact. 0.74. What is the ratio of the Taxes (in $) in Taxes on goods and services in 1991 to that in 1993?
Keep it short and to the point. 0.7. What is the ratio of the Taxes (in $) in Taxes on income in 1991 to that in 1993?
Keep it short and to the point. 1.13. What is the ratio of the Taxes (in $) of Taxes on revenue in 1991 to that in 1994?
Ensure brevity in your answer.  0.64. What is the ratio of the Taxes (in $) in Taxes on exports in 1991 to that in 1994?
Ensure brevity in your answer.  0.56. What is the ratio of the Taxes (in $) of Taxes on goods and services in 1991 to that in 1994?
Give a very brief answer. 0.52. What is the ratio of the Taxes (in $) of Taxes on income in 1991 to that in 1994?
Your response must be concise. 1.01. What is the ratio of the Taxes (in $) in Taxes on revenue in 1991 to that in 1995?
Make the answer very short. 0.53. What is the ratio of the Taxes (in $) in Taxes on exports in 1991 to that in 1995?
Your answer should be very brief. 0.44. What is the ratio of the Taxes (in $) in Taxes on goods and services in 1991 to that in 1995?
Give a very brief answer. 0.43. What is the ratio of the Taxes (in $) in Taxes on income in 1991 to that in 1995?
Give a very brief answer. 0.8. What is the ratio of the Taxes (in $) of Taxes on exports in 1992 to that in 1993?
Provide a short and direct response. 0.81. What is the ratio of the Taxes (in $) of Taxes on goods and services in 1992 to that in 1993?
Make the answer very short. 1.07. What is the ratio of the Taxes (in $) in Taxes on income in 1992 to that in 1993?
Your answer should be compact. 1.17. What is the ratio of the Taxes (in $) in Taxes on revenue in 1992 to that in 1994?
Provide a short and direct response. 0.82. What is the ratio of the Taxes (in $) of Taxes on exports in 1992 to that in 1994?
Provide a short and direct response. 0.61. What is the ratio of the Taxes (in $) of Taxes on goods and services in 1992 to that in 1994?
Your answer should be compact. 0.8. What is the ratio of the Taxes (in $) in Taxes on income in 1992 to that in 1994?
Offer a terse response. 1.05. What is the ratio of the Taxes (in $) of Taxes on revenue in 1992 to that in 1995?
Make the answer very short. 0.68. What is the ratio of the Taxes (in $) in Taxes on exports in 1992 to that in 1995?
Your answer should be very brief. 0.48. What is the ratio of the Taxes (in $) of Taxes on goods and services in 1992 to that in 1995?
Provide a succinct answer. 0.67. What is the ratio of the Taxes (in $) of Taxes on income in 1992 to that in 1995?
Give a very brief answer. 0.83. What is the ratio of the Taxes (in $) in Taxes on revenue in 1993 to that in 1994?
Ensure brevity in your answer.  0.82. What is the ratio of the Taxes (in $) in Taxes on exports in 1993 to that in 1994?
Ensure brevity in your answer.  0.76. What is the ratio of the Taxes (in $) in Taxes on goods and services in 1993 to that in 1994?
Provide a short and direct response. 0.74. What is the ratio of the Taxes (in $) in Taxes on income in 1993 to that in 1994?
Offer a terse response. 0.9. What is the ratio of the Taxes (in $) in Taxes on revenue in 1993 to that in 1995?
Make the answer very short. 0.68. What is the ratio of the Taxes (in $) of Taxes on exports in 1993 to that in 1995?
Make the answer very short. 0.6. What is the ratio of the Taxes (in $) of Taxes on goods and services in 1993 to that in 1995?
Your answer should be compact. 0.62. What is the ratio of the Taxes (in $) of Taxes on income in 1993 to that in 1995?
Provide a succinct answer. 0.71. What is the ratio of the Taxes (in $) in Taxes on revenue in 1994 to that in 1995?
Your response must be concise. 0.83. What is the ratio of the Taxes (in $) in Taxes on exports in 1994 to that in 1995?
Give a very brief answer. 0.79. What is the ratio of the Taxes (in $) in Taxes on goods and services in 1994 to that in 1995?
Your response must be concise. 0.84. What is the ratio of the Taxes (in $) of Taxes on income in 1994 to that in 1995?
Make the answer very short. 0.79. What is the difference between the highest and the second highest Taxes (in $) in Taxes on revenue?
Ensure brevity in your answer.  1.80e+1. What is the difference between the highest and the second highest Taxes (in $) of Taxes on exports?
Offer a terse response. 6.72e+08. What is the difference between the highest and the second highest Taxes (in $) in Taxes on goods and services?
Offer a terse response. 7.78e+09. What is the difference between the highest and the second highest Taxes (in $) in Taxes on income?
Provide a short and direct response. 5.32e+09. What is the difference between the highest and the lowest Taxes (in $) of Taxes on revenue?
Your answer should be very brief. 6.15e+1. What is the difference between the highest and the lowest Taxes (in $) of Taxes on exports?
Your response must be concise. 2.54e+09. What is the difference between the highest and the lowest Taxes (in $) of Taxes on goods and services?
Give a very brief answer. 2.98e+1. What is the difference between the highest and the lowest Taxes (in $) of Taxes on income?
Your answer should be compact. 1.27e+1. 